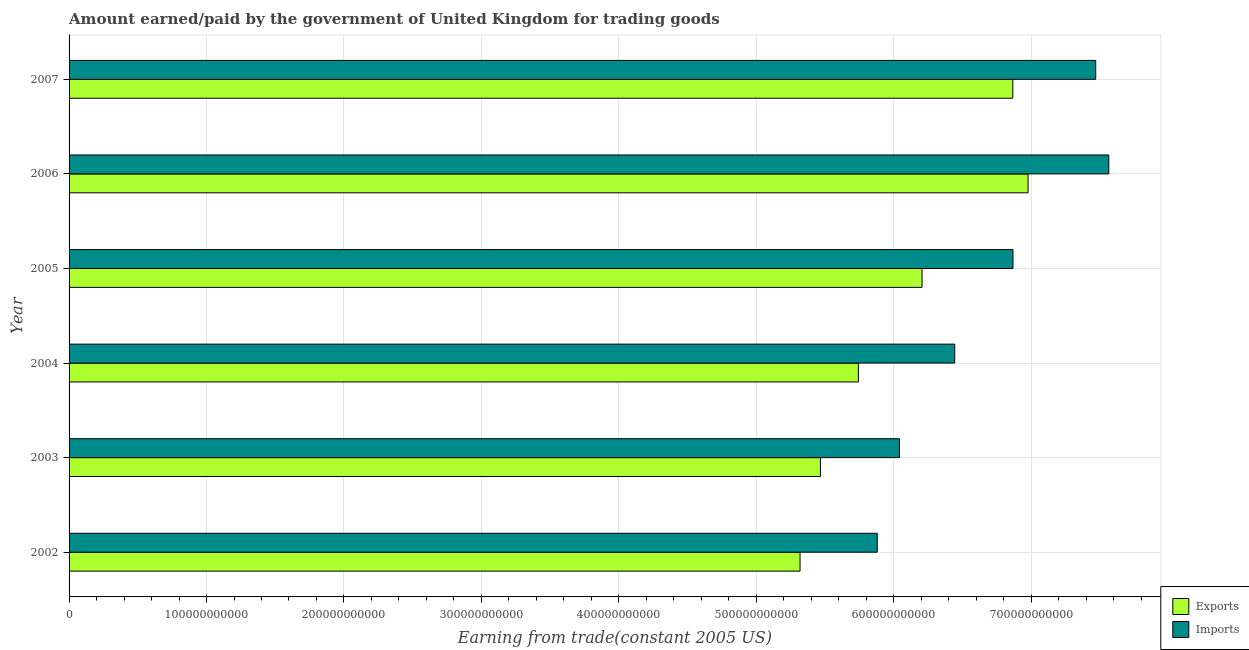How many bars are there on the 5th tick from the top?
Your answer should be compact. 2. How many bars are there on the 3rd tick from the bottom?
Give a very brief answer. 2. What is the label of the 6th group of bars from the top?
Your answer should be very brief. 2002. In how many cases, is the number of bars for a given year not equal to the number of legend labels?
Ensure brevity in your answer.  0. What is the amount paid for imports in 2006?
Offer a very short reply. 7.56e+11. Across all years, what is the maximum amount earned from exports?
Offer a very short reply. 6.98e+11. Across all years, what is the minimum amount earned from exports?
Ensure brevity in your answer.  5.32e+11. In which year was the amount earned from exports maximum?
Your response must be concise. 2006. What is the total amount paid for imports in the graph?
Keep it short and to the point. 4.03e+12. What is the difference between the amount paid for imports in 2002 and that in 2006?
Make the answer very short. -1.68e+11. What is the difference between the amount earned from exports in 2002 and the amount paid for imports in 2007?
Offer a very short reply. -2.15e+11. What is the average amount earned from exports per year?
Keep it short and to the point. 6.10e+11. In the year 2004, what is the difference between the amount earned from exports and amount paid for imports?
Provide a short and direct response. -7.01e+1. In how many years, is the amount earned from exports greater than 260000000000 US$?
Ensure brevity in your answer.  6. What is the ratio of the amount paid for imports in 2003 to that in 2004?
Ensure brevity in your answer.  0.94. Is the amount earned from exports in 2004 less than that in 2006?
Provide a succinct answer. Yes. Is the difference between the amount paid for imports in 2004 and 2006 greater than the difference between the amount earned from exports in 2004 and 2006?
Keep it short and to the point. Yes. What is the difference between the highest and the second highest amount earned from exports?
Provide a short and direct response. 1.11e+1. What is the difference between the highest and the lowest amount paid for imports?
Keep it short and to the point. 1.68e+11. What does the 1st bar from the top in 2004 represents?
Your answer should be very brief. Imports. What does the 2nd bar from the bottom in 2003 represents?
Give a very brief answer. Imports. How many bars are there?
Provide a short and direct response. 12. How many years are there in the graph?
Provide a succinct answer. 6. What is the difference between two consecutive major ticks on the X-axis?
Offer a very short reply. 1.00e+11. Are the values on the major ticks of X-axis written in scientific E-notation?
Your answer should be compact. No. Does the graph contain grids?
Your response must be concise. Yes. How many legend labels are there?
Your answer should be very brief. 2. How are the legend labels stacked?
Ensure brevity in your answer.  Vertical. What is the title of the graph?
Ensure brevity in your answer.  Amount earned/paid by the government of United Kingdom for trading goods. Does "From production" appear as one of the legend labels in the graph?
Your answer should be compact. No. What is the label or title of the X-axis?
Provide a succinct answer. Earning from trade(constant 2005 US). What is the label or title of the Y-axis?
Ensure brevity in your answer.  Year. What is the Earning from trade(constant 2005 US) in Exports in 2002?
Your answer should be compact. 5.32e+11. What is the Earning from trade(constant 2005 US) in Imports in 2002?
Your response must be concise. 5.88e+11. What is the Earning from trade(constant 2005 US) in Exports in 2003?
Keep it short and to the point. 5.47e+11. What is the Earning from trade(constant 2005 US) in Imports in 2003?
Provide a short and direct response. 6.04e+11. What is the Earning from trade(constant 2005 US) of Exports in 2004?
Your answer should be very brief. 5.74e+11. What is the Earning from trade(constant 2005 US) of Imports in 2004?
Provide a succinct answer. 6.44e+11. What is the Earning from trade(constant 2005 US) of Exports in 2005?
Give a very brief answer. 6.21e+11. What is the Earning from trade(constant 2005 US) in Imports in 2005?
Keep it short and to the point. 6.87e+11. What is the Earning from trade(constant 2005 US) in Exports in 2006?
Give a very brief answer. 6.98e+11. What is the Earning from trade(constant 2005 US) in Imports in 2006?
Offer a very short reply. 7.56e+11. What is the Earning from trade(constant 2005 US) of Exports in 2007?
Make the answer very short. 6.87e+11. What is the Earning from trade(constant 2005 US) of Imports in 2007?
Your answer should be very brief. 7.47e+11. Across all years, what is the maximum Earning from trade(constant 2005 US) in Exports?
Give a very brief answer. 6.98e+11. Across all years, what is the maximum Earning from trade(constant 2005 US) of Imports?
Your answer should be compact. 7.56e+11. Across all years, what is the minimum Earning from trade(constant 2005 US) in Exports?
Your answer should be compact. 5.32e+11. Across all years, what is the minimum Earning from trade(constant 2005 US) of Imports?
Ensure brevity in your answer.  5.88e+11. What is the total Earning from trade(constant 2005 US) of Exports in the graph?
Your answer should be very brief. 3.66e+12. What is the total Earning from trade(constant 2005 US) in Imports in the graph?
Your answer should be compact. 4.03e+12. What is the difference between the Earning from trade(constant 2005 US) in Exports in 2002 and that in 2003?
Give a very brief answer. -1.48e+1. What is the difference between the Earning from trade(constant 2005 US) in Imports in 2002 and that in 2003?
Provide a succinct answer. -1.61e+1. What is the difference between the Earning from trade(constant 2005 US) in Exports in 2002 and that in 2004?
Ensure brevity in your answer.  -4.25e+1. What is the difference between the Earning from trade(constant 2005 US) of Imports in 2002 and that in 2004?
Provide a succinct answer. -5.64e+1. What is the difference between the Earning from trade(constant 2005 US) of Exports in 2002 and that in 2005?
Offer a very short reply. -8.88e+1. What is the difference between the Earning from trade(constant 2005 US) in Imports in 2002 and that in 2005?
Ensure brevity in your answer.  -9.88e+1. What is the difference between the Earning from trade(constant 2005 US) of Exports in 2002 and that in 2006?
Offer a very short reply. -1.66e+11. What is the difference between the Earning from trade(constant 2005 US) of Imports in 2002 and that in 2006?
Ensure brevity in your answer.  -1.68e+11. What is the difference between the Earning from trade(constant 2005 US) of Exports in 2002 and that in 2007?
Offer a terse response. -1.55e+11. What is the difference between the Earning from trade(constant 2005 US) in Imports in 2002 and that in 2007?
Ensure brevity in your answer.  -1.59e+11. What is the difference between the Earning from trade(constant 2005 US) of Exports in 2003 and that in 2004?
Provide a short and direct response. -2.76e+1. What is the difference between the Earning from trade(constant 2005 US) of Imports in 2003 and that in 2004?
Make the answer very short. -4.02e+1. What is the difference between the Earning from trade(constant 2005 US) in Exports in 2003 and that in 2005?
Make the answer very short. -7.39e+1. What is the difference between the Earning from trade(constant 2005 US) in Imports in 2003 and that in 2005?
Make the answer very short. -8.26e+1. What is the difference between the Earning from trade(constant 2005 US) in Exports in 2003 and that in 2006?
Provide a short and direct response. -1.51e+11. What is the difference between the Earning from trade(constant 2005 US) in Imports in 2003 and that in 2006?
Your answer should be compact. -1.52e+11. What is the difference between the Earning from trade(constant 2005 US) in Exports in 2003 and that in 2007?
Make the answer very short. -1.40e+11. What is the difference between the Earning from trade(constant 2005 US) in Imports in 2003 and that in 2007?
Offer a terse response. -1.43e+11. What is the difference between the Earning from trade(constant 2005 US) of Exports in 2004 and that in 2005?
Ensure brevity in your answer.  -4.63e+1. What is the difference between the Earning from trade(constant 2005 US) of Imports in 2004 and that in 2005?
Provide a succinct answer. -4.24e+1. What is the difference between the Earning from trade(constant 2005 US) of Exports in 2004 and that in 2006?
Make the answer very short. -1.23e+11. What is the difference between the Earning from trade(constant 2005 US) in Imports in 2004 and that in 2006?
Provide a short and direct response. -1.12e+11. What is the difference between the Earning from trade(constant 2005 US) of Exports in 2004 and that in 2007?
Offer a very short reply. -1.12e+11. What is the difference between the Earning from trade(constant 2005 US) in Imports in 2004 and that in 2007?
Make the answer very short. -1.03e+11. What is the difference between the Earning from trade(constant 2005 US) of Exports in 2005 and that in 2006?
Offer a terse response. -7.71e+1. What is the difference between the Earning from trade(constant 2005 US) of Imports in 2005 and that in 2006?
Offer a very short reply. -6.97e+1. What is the difference between the Earning from trade(constant 2005 US) in Exports in 2005 and that in 2007?
Give a very brief answer. -6.60e+1. What is the difference between the Earning from trade(constant 2005 US) of Imports in 2005 and that in 2007?
Make the answer very short. -6.02e+1. What is the difference between the Earning from trade(constant 2005 US) in Exports in 2006 and that in 2007?
Give a very brief answer. 1.11e+1. What is the difference between the Earning from trade(constant 2005 US) in Imports in 2006 and that in 2007?
Ensure brevity in your answer.  9.52e+09. What is the difference between the Earning from trade(constant 2005 US) in Exports in 2002 and the Earning from trade(constant 2005 US) in Imports in 2003?
Your response must be concise. -7.23e+1. What is the difference between the Earning from trade(constant 2005 US) in Exports in 2002 and the Earning from trade(constant 2005 US) in Imports in 2004?
Ensure brevity in your answer.  -1.13e+11. What is the difference between the Earning from trade(constant 2005 US) of Exports in 2002 and the Earning from trade(constant 2005 US) of Imports in 2005?
Keep it short and to the point. -1.55e+11. What is the difference between the Earning from trade(constant 2005 US) of Exports in 2002 and the Earning from trade(constant 2005 US) of Imports in 2006?
Ensure brevity in your answer.  -2.25e+11. What is the difference between the Earning from trade(constant 2005 US) in Exports in 2002 and the Earning from trade(constant 2005 US) in Imports in 2007?
Give a very brief answer. -2.15e+11. What is the difference between the Earning from trade(constant 2005 US) in Exports in 2003 and the Earning from trade(constant 2005 US) in Imports in 2004?
Your response must be concise. -9.77e+1. What is the difference between the Earning from trade(constant 2005 US) in Exports in 2003 and the Earning from trade(constant 2005 US) in Imports in 2005?
Provide a succinct answer. -1.40e+11. What is the difference between the Earning from trade(constant 2005 US) in Exports in 2003 and the Earning from trade(constant 2005 US) in Imports in 2006?
Your answer should be compact. -2.10e+11. What is the difference between the Earning from trade(constant 2005 US) of Exports in 2003 and the Earning from trade(constant 2005 US) of Imports in 2007?
Your answer should be very brief. -2.00e+11. What is the difference between the Earning from trade(constant 2005 US) in Exports in 2004 and the Earning from trade(constant 2005 US) in Imports in 2005?
Keep it short and to the point. -1.12e+11. What is the difference between the Earning from trade(constant 2005 US) in Exports in 2004 and the Earning from trade(constant 2005 US) in Imports in 2006?
Your answer should be very brief. -1.82e+11. What is the difference between the Earning from trade(constant 2005 US) in Exports in 2004 and the Earning from trade(constant 2005 US) in Imports in 2007?
Make the answer very short. -1.73e+11. What is the difference between the Earning from trade(constant 2005 US) in Exports in 2005 and the Earning from trade(constant 2005 US) in Imports in 2006?
Provide a succinct answer. -1.36e+11. What is the difference between the Earning from trade(constant 2005 US) of Exports in 2005 and the Earning from trade(constant 2005 US) of Imports in 2007?
Your answer should be very brief. -1.26e+11. What is the difference between the Earning from trade(constant 2005 US) of Exports in 2006 and the Earning from trade(constant 2005 US) of Imports in 2007?
Give a very brief answer. -4.92e+1. What is the average Earning from trade(constant 2005 US) in Exports per year?
Give a very brief answer. 6.10e+11. What is the average Earning from trade(constant 2005 US) in Imports per year?
Your response must be concise. 6.71e+11. In the year 2002, what is the difference between the Earning from trade(constant 2005 US) of Exports and Earning from trade(constant 2005 US) of Imports?
Offer a very short reply. -5.62e+1. In the year 2003, what is the difference between the Earning from trade(constant 2005 US) in Exports and Earning from trade(constant 2005 US) in Imports?
Make the answer very short. -5.75e+1. In the year 2004, what is the difference between the Earning from trade(constant 2005 US) of Exports and Earning from trade(constant 2005 US) of Imports?
Ensure brevity in your answer.  -7.01e+1. In the year 2005, what is the difference between the Earning from trade(constant 2005 US) in Exports and Earning from trade(constant 2005 US) in Imports?
Offer a terse response. -6.62e+1. In the year 2006, what is the difference between the Earning from trade(constant 2005 US) of Exports and Earning from trade(constant 2005 US) of Imports?
Make the answer very short. -5.87e+1. In the year 2007, what is the difference between the Earning from trade(constant 2005 US) of Exports and Earning from trade(constant 2005 US) of Imports?
Make the answer very short. -6.03e+1. What is the ratio of the Earning from trade(constant 2005 US) of Exports in 2002 to that in 2003?
Your response must be concise. 0.97. What is the ratio of the Earning from trade(constant 2005 US) in Imports in 2002 to that in 2003?
Offer a very short reply. 0.97. What is the ratio of the Earning from trade(constant 2005 US) of Exports in 2002 to that in 2004?
Offer a terse response. 0.93. What is the ratio of the Earning from trade(constant 2005 US) of Imports in 2002 to that in 2004?
Offer a terse response. 0.91. What is the ratio of the Earning from trade(constant 2005 US) of Exports in 2002 to that in 2005?
Give a very brief answer. 0.86. What is the ratio of the Earning from trade(constant 2005 US) in Imports in 2002 to that in 2005?
Ensure brevity in your answer.  0.86. What is the ratio of the Earning from trade(constant 2005 US) in Exports in 2002 to that in 2006?
Your answer should be compact. 0.76. What is the ratio of the Earning from trade(constant 2005 US) in Imports in 2002 to that in 2006?
Provide a short and direct response. 0.78. What is the ratio of the Earning from trade(constant 2005 US) in Exports in 2002 to that in 2007?
Your response must be concise. 0.77. What is the ratio of the Earning from trade(constant 2005 US) of Imports in 2002 to that in 2007?
Make the answer very short. 0.79. What is the ratio of the Earning from trade(constant 2005 US) in Exports in 2003 to that in 2004?
Your answer should be very brief. 0.95. What is the ratio of the Earning from trade(constant 2005 US) of Imports in 2003 to that in 2004?
Offer a terse response. 0.94. What is the ratio of the Earning from trade(constant 2005 US) of Exports in 2003 to that in 2005?
Offer a terse response. 0.88. What is the ratio of the Earning from trade(constant 2005 US) in Imports in 2003 to that in 2005?
Provide a succinct answer. 0.88. What is the ratio of the Earning from trade(constant 2005 US) of Exports in 2003 to that in 2006?
Your answer should be very brief. 0.78. What is the ratio of the Earning from trade(constant 2005 US) of Imports in 2003 to that in 2006?
Offer a very short reply. 0.8. What is the ratio of the Earning from trade(constant 2005 US) in Exports in 2003 to that in 2007?
Your answer should be very brief. 0.8. What is the ratio of the Earning from trade(constant 2005 US) in Imports in 2003 to that in 2007?
Provide a succinct answer. 0.81. What is the ratio of the Earning from trade(constant 2005 US) in Exports in 2004 to that in 2005?
Offer a very short reply. 0.93. What is the ratio of the Earning from trade(constant 2005 US) in Imports in 2004 to that in 2005?
Provide a short and direct response. 0.94. What is the ratio of the Earning from trade(constant 2005 US) in Exports in 2004 to that in 2006?
Ensure brevity in your answer.  0.82. What is the ratio of the Earning from trade(constant 2005 US) in Imports in 2004 to that in 2006?
Offer a terse response. 0.85. What is the ratio of the Earning from trade(constant 2005 US) in Exports in 2004 to that in 2007?
Provide a short and direct response. 0.84. What is the ratio of the Earning from trade(constant 2005 US) in Imports in 2004 to that in 2007?
Ensure brevity in your answer.  0.86. What is the ratio of the Earning from trade(constant 2005 US) in Exports in 2005 to that in 2006?
Keep it short and to the point. 0.89. What is the ratio of the Earning from trade(constant 2005 US) of Imports in 2005 to that in 2006?
Your response must be concise. 0.91. What is the ratio of the Earning from trade(constant 2005 US) of Exports in 2005 to that in 2007?
Provide a succinct answer. 0.9. What is the ratio of the Earning from trade(constant 2005 US) of Imports in 2005 to that in 2007?
Your answer should be compact. 0.92. What is the ratio of the Earning from trade(constant 2005 US) in Exports in 2006 to that in 2007?
Offer a very short reply. 1.02. What is the ratio of the Earning from trade(constant 2005 US) in Imports in 2006 to that in 2007?
Your answer should be compact. 1.01. What is the difference between the highest and the second highest Earning from trade(constant 2005 US) in Exports?
Your response must be concise. 1.11e+1. What is the difference between the highest and the second highest Earning from trade(constant 2005 US) in Imports?
Give a very brief answer. 9.52e+09. What is the difference between the highest and the lowest Earning from trade(constant 2005 US) of Exports?
Offer a terse response. 1.66e+11. What is the difference between the highest and the lowest Earning from trade(constant 2005 US) of Imports?
Provide a succinct answer. 1.68e+11. 